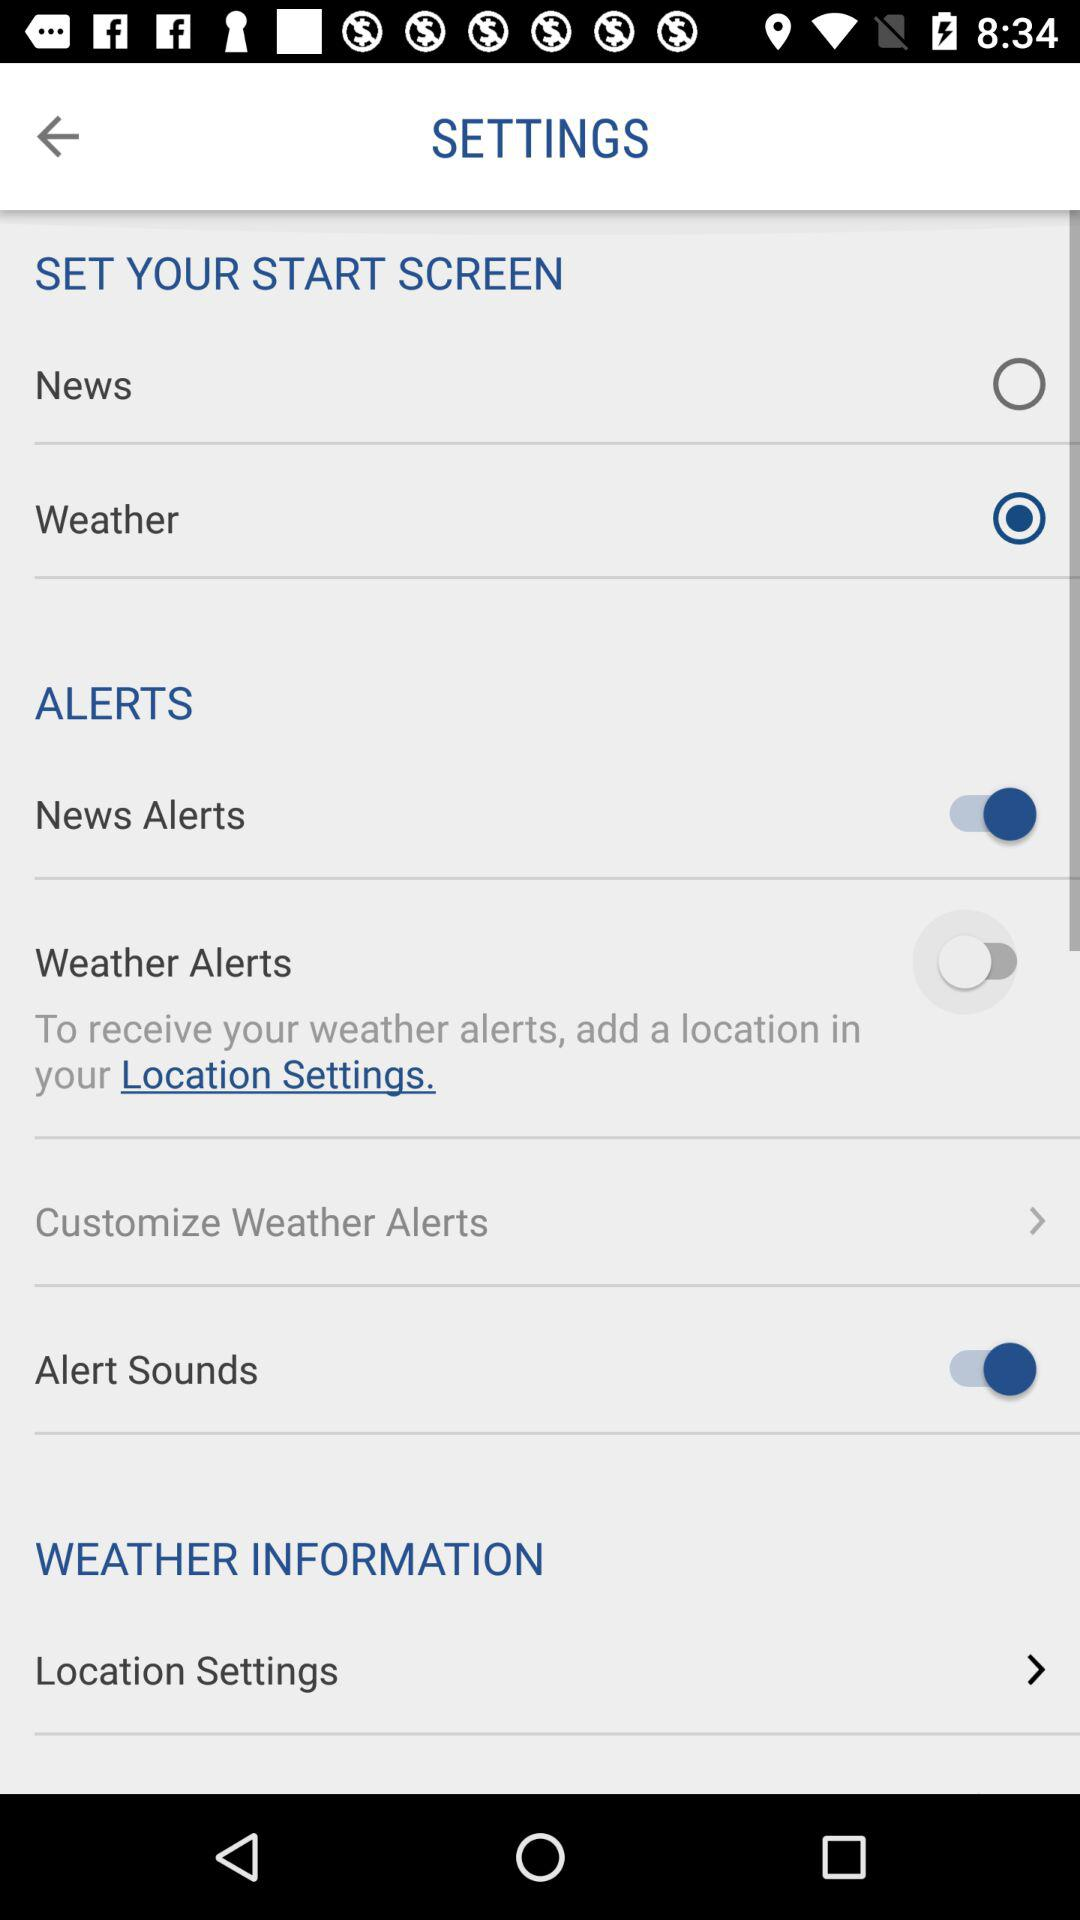Which is the selected option? The selected option is weather. 